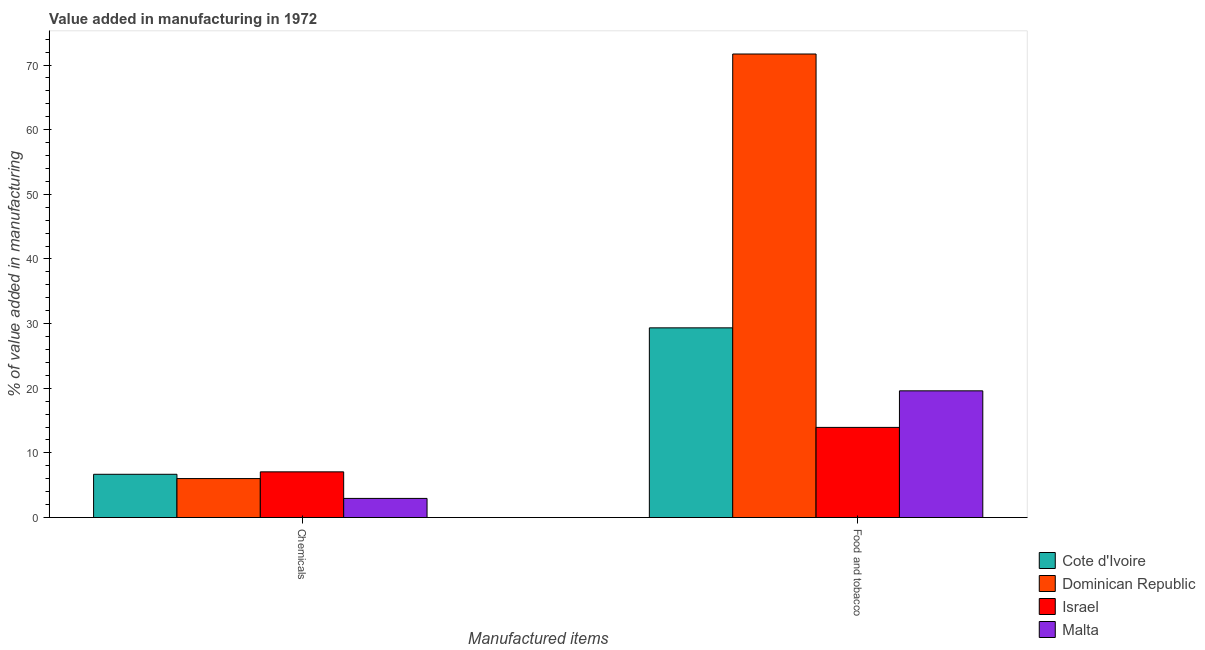How many different coloured bars are there?
Make the answer very short. 4. Are the number of bars per tick equal to the number of legend labels?
Offer a terse response. Yes. What is the label of the 1st group of bars from the left?
Your answer should be compact. Chemicals. What is the value added by manufacturing food and tobacco in Dominican Republic?
Provide a succinct answer. 71.7. Across all countries, what is the maximum value added by manufacturing food and tobacco?
Offer a terse response. 71.7. Across all countries, what is the minimum value added by  manufacturing chemicals?
Offer a terse response. 2.96. In which country was the value added by  manufacturing chemicals minimum?
Your response must be concise. Malta. What is the total value added by  manufacturing chemicals in the graph?
Offer a terse response. 22.75. What is the difference between the value added by manufacturing food and tobacco in Malta and that in Israel?
Your answer should be very brief. 5.65. What is the difference between the value added by manufacturing food and tobacco in Israel and the value added by  manufacturing chemicals in Cote d'Ivoire?
Keep it short and to the point. 7.26. What is the average value added by  manufacturing chemicals per country?
Make the answer very short. 5.69. What is the difference between the value added by  manufacturing chemicals and value added by manufacturing food and tobacco in Dominican Republic?
Keep it short and to the point. -65.67. What is the ratio of the value added by manufacturing food and tobacco in Malta to that in Dominican Republic?
Keep it short and to the point. 0.27. What does the 1st bar from the right in Chemicals represents?
Keep it short and to the point. Malta. How many bars are there?
Provide a succinct answer. 8. Are all the bars in the graph horizontal?
Provide a succinct answer. No. How many countries are there in the graph?
Your answer should be compact. 4. What is the difference between two consecutive major ticks on the Y-axis?
Provide a succinct answer. 10. Does the graph contain any zero values?
Keep it short and to the point. No. Where does the legend appear in the graph?
Your response must be concise. Bottom right. What is the title of the graph?
Give a very brief answer. Value added in manufacturing in 1972. What is the label or title of the X-axis?
Your answer should be compact. Manufactured items. What is the label or title of the Y-axis?
Give a very brief answer. % of value added in manufacturing. What is the % of value added in manufacturing of Cote d'Ivoire in Chemicals?
Give a very brief answer. 6.69. What is the % of value added in manufacturing of Dominican Republic in Chemicals?
Provide a succinct answer. 6.03. What is the % of value added in manufacturing in Israel in Chemicals?
Give a very brief answer. 7.07. What is the % of value added in manufacturing of Malta in Chemicals?
Your answer should be very brief. 2.96. What is the % of value added in manufacturing in Cote d'Ivoire in Food and tobacco?
Your answer should be very brief. 29.34. What is the % of value added in manufacturing in Dominican Republic in Food and tobacco?
Your answer should be compact. 71.7. What is the % of value added in manufacturing of Israel in Food and tobacco?
Provide a short and direct response. 13.95. What is the % of value added in manufacturing in Malta in Food and tobacco?
Make the answer very short. 19.6. Across all Manufactured items, what is the maximum % of value added in manufacturing of Cote d'Ivoire?
Provide a succinct answer. 29.34. Across all Manufactured items, what is the maximum % of value added in manufacturing in Dominican Republic?
Provide a succinct answer. 71.7. Across all Manufactured items, what is the maximum % of value added in manufacturing in Israel?
Offer a very short reply. 13.95. Across all Manufactured items, what is the maximum % of value added in manufacturing in Malta?
Your response must be concise. 19.6. Across all Manufactured items, what is the minimum % of value added in manufacturing in Cote d'Ivoire?
Your response must be concise. 6.69. Across all Manufactured items, what is the minimum % of value added in manufacturing in Dominican Republic?
Provide a short and direct response. 6.03. Across all Manufactured items, what is the minimum % of value added in manufacturing of Israel?
Provide a short and direct response. 7.07. Across all Manufactured items, what is the minimum % of value added in manufacturing in Malta?
Make the answer very short. 2.96. What is the total % of value added in manufacturing in Cote d'Ivoire in the graph?
Keep it short and to the point. 36.04. What is the total % of value added in manufacturing in Dominican Republic in the graph?
Give a very brief answer. 77.74. What is the total % of value added in manufacturing of Israel in the graph?
Keep it short and to the point. 21.02. What is the total % of value added in manufacturing in Malta in the graph?
Keep it short and to the point. 22.56. What is the difference between the % of value added in manufacturing in Cote d'Ivoire in Chemicals and that in Food and tobacco?
Provide a succinct answer. -22.65. What is the difference between the % of value added in manufacturing of Dominican Republic in Chemicals and that in Food and tobacco?
Your answer should be compact. -65.67. What is the difference between the % of value added in manufacturing of Israel in Chemicals and that in Food and tobacco?
Offer a very short reply. -6.88. What is the difference between the % of value added in manufacturing of Malta in Chemicals and that in Food and tobacco?
Offer a terse response. -16.64. What is the difference between the % of value added in manufacturing in Cote d'Ivoire in Chemicals and the % of value added in manufacturing in Dominican Republic in Food and tobacco?
Keep it short and to the point. -65.01. What is the difference between the % of value added in manufacturing in Cote d'Ivoire in Chemicals and the % of value added in manufacturing in Israel in Food and tobacco?
Your answer should be very brief. -7.26. What is the difference between the % of value added in manufacturing in Cote d'Ivoire in Chemicals and the % of value added in manufacturing in Malta in Food and tobacco?
Keep it short and to the point. -12.91. What is the difference between the % of value added in manufacturing in Dominican Republic in Chemicals and the % of value added in manufacturing in Israel in Food and tobacco?
Make the answer very short. -7.92. What is the difference between the % of value added in manufacturing of Dominican Republic in Chemicals and the % of value added in manufacturing of Malta in Food and tobacco?
Make the answer very short. -13.57. What is the difference between the % of value added in manufacturing in Israel in Chemicals and the % of value added in manufacturing in Malta in Food and tobacco?
Ensure brevity in your answer.  -12.53. What is the average % of value added in manufacturing of Cote d'Ivoire per Manufactured items?
Provide a short and direct response. 18.02. What is the average % of value added in manufacturing in Dominican Republic per Manufactured items?
Ensure brevity in your answer.  38.87. What is the average % of value added in manufacturing in Israel per Manufactured items?
Provide a short and direct response. 10.51. What is the average % of value added in manufacturing in Malta per Manufactured items?
Give a very brief answer. 11.28. What is the difference between the % of value added in manufacturing in Cote d'Ivoire and % of value added in manufacturing in Dominican Republic in Chemicals?
Make the answer very short. 0.66. What is the difference between the % of value added in manufacturing of Cote d'Ivoire and % of value added in manufacturing of Israel in Chemicals?
Your answer should be very brief. -0.38. What is the difference between the % of value added in manufacturing in Cote d'Ivoire and % of value added in manufacturing in Malta in Chemicals?
Offer a terse response. 3.73. What is the difference between the % of value added in manufacturing in Dominican Republic and % of value added in manufacturing in Israel in Chemicals?
Make the answer very short. -1.04. What is the difference between the % of value added in manufacturing of Dominican Republic and % of value added in manufacturing of Malta in Chemicals?
Provide a short and direct response. 3.07. What is the difference between the % of value added in manufacturing in Israel and % of value added in manufacturing in Malta in Chemicals?
Offer a very short reply. 4.11. What is the difference between the % of value added in manufacturing of Cote d'Ivoire and % of value added in manufacturing of Dominican Republic in Food and tobacco?
Offer a very short reply. -42.36. What is the difference between the % of value added in manufacturing in Cote d'Ivoire and % of value added in manufacturing in Israel in Food and tobacco?
Ensure brevity in your answer.  15.4. What is the difference between the % of value added in manufacturing in Cote d'Ivoire and % of value added in manufacturing in Malta in Food and tobacco?
Provide a succinct answer. 9.74. What is the difference between the % of value added in manufacturing in Dominican Republic and % of value added in manufacturing in Israel in Food and tobacco?
Your answer should be very brief. 57.76. What is the difference between the % of value added in manufacturing of Dominican Republic and % of value added in manufacturing of Malta in Food and tobacco?
Offer a very short reply. 52.1. What is the difference between the % of value added in manufacturing of Israel and % of value added in manufacturing of Malta in Food and tobacco?
Make the answer very short. -5.65. What is the ratio of the % of value added in manufacturing in Cote d'Ivoire in Chemicals to that in Food and tobacco?
Offer a very short reply. 0.23. What is the ratio of the % of value added in manufacturing in Dominican Republic in Chemicals to that in Food and tobacco?
Provide a succinct answer. 0.08. What is the ratio of the % of value added in manufacturing of Israel in Chemicals to that in Food and tobacco?
Your response must be concise. 0.51. What is the ratio of the % of value added in manufacturing in Malta in Chemicals to that in Food and tobacco?
Offer a terse response. 0.15. What is the difference between the highest and the second highest % of value added in manufacturing of Cote d'Ivoire?
Your answer should be compact. 22.65. What is the difference between the highest and the second highest % of value added in manufacturing in Dominican Republic?
Keep it short and to the point. 65.67. What is the difference between the highest and the second highest % of value added in manufacturing of Israel?
Offer a very short reply. 6.88. What is the difference between the highest and the second highest % of value added in manufacturing of Malta?
Provide a short and direct response. 16.64. What is the difference between the highest and the lowest % of value added in manufacturing in Cote d'Ivoire?
Give a very brief answer. 22.65. What is the difference between the highest and the lowest % of value added in manufacturing of Dominican Republic?
Provide a short and direct response. 65.67. What is the difference between the highest and the lowest % of value added in manufacturing in Israel?
Provide a succinct answer. 6.88. What is the difference between the highest and the lowest % of value added in manufacturing of Malta?
Keep it short and to the point. 16.64. 